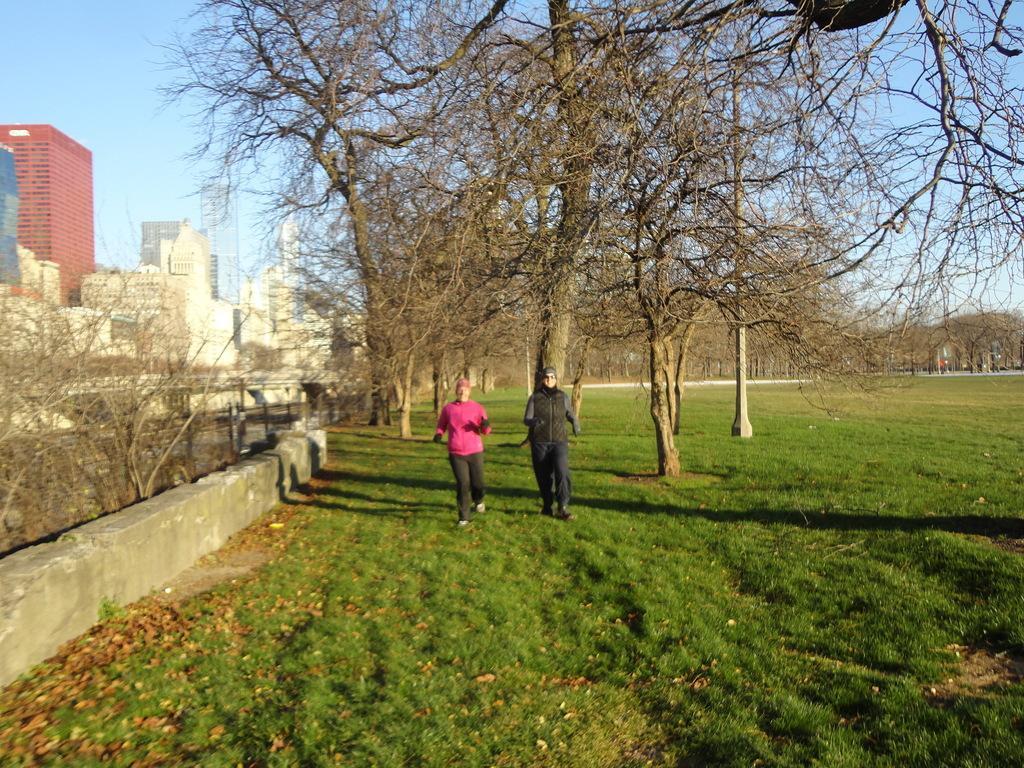Describe this image in one or two sentences. In this image I see 2 persons over here and I see the green grass. In the background I see number of trees, buildings and the blue sky. 